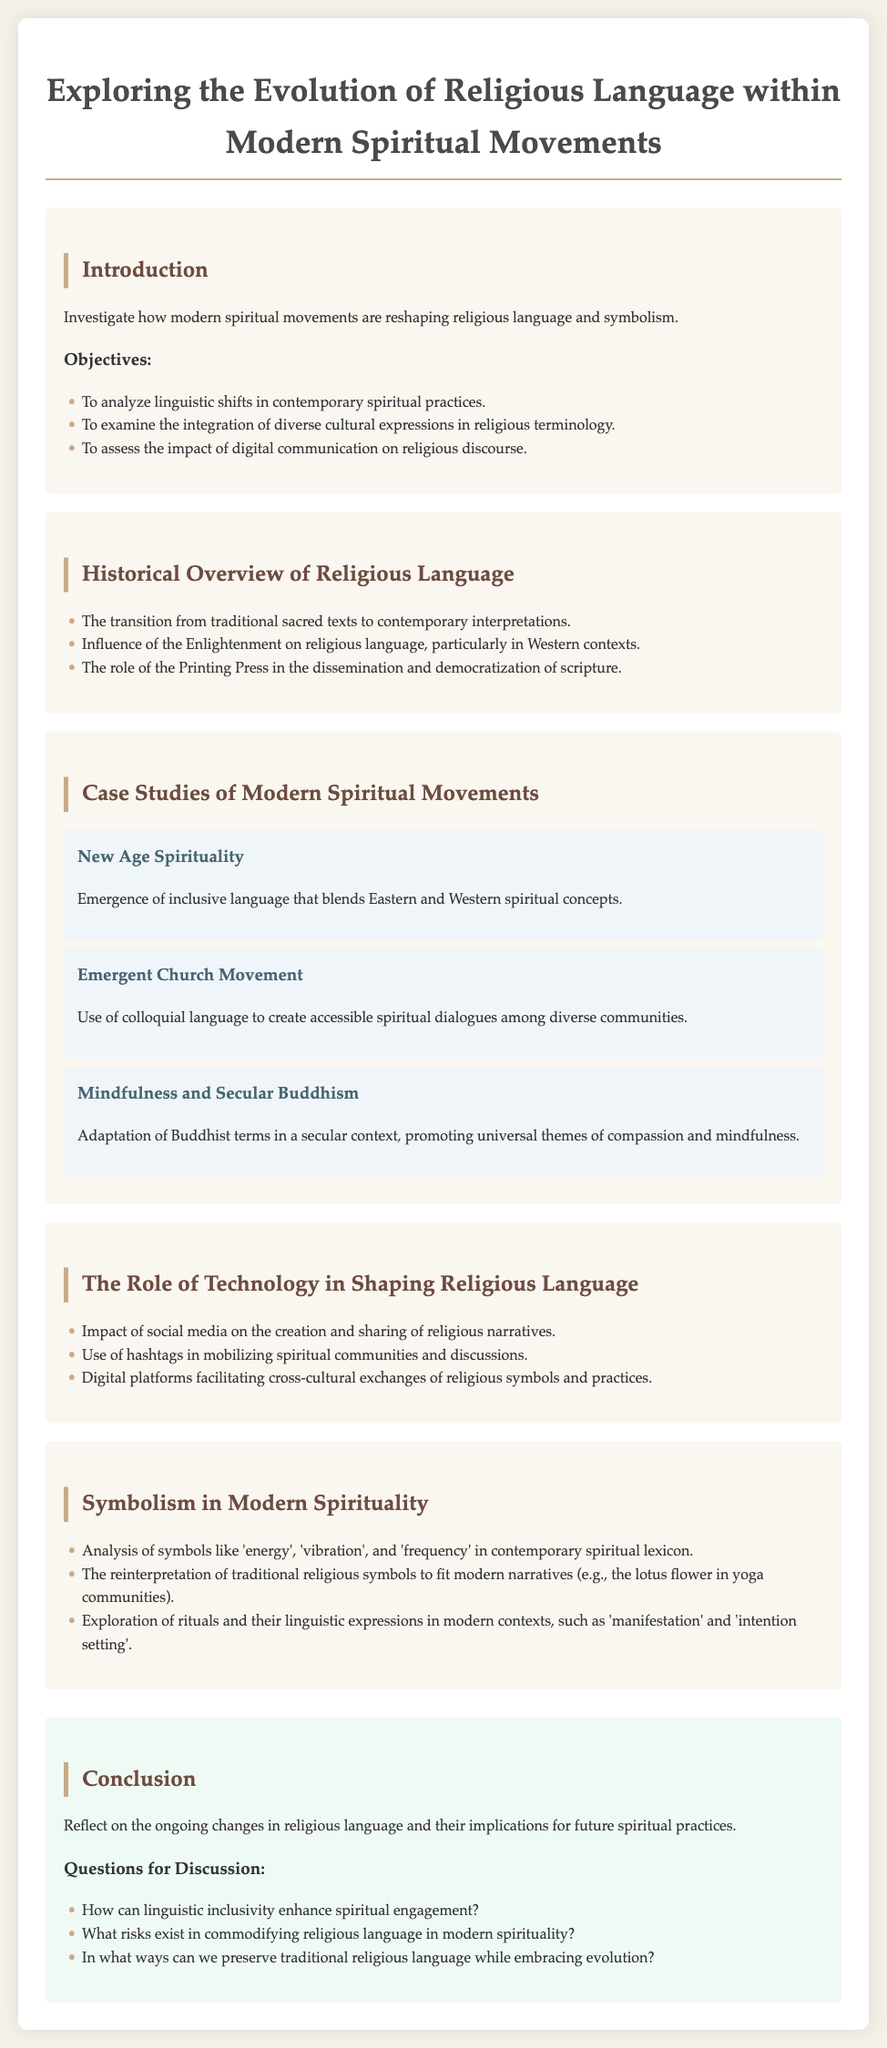What is the title of the document? The title is stated in the header of the document, which is "Exploring the Evolution of Religious Language within Modern Spiritual Movements."
Answer: Exploring the Evolution of Religious Language within Modern Spiritual Movements What are the three objectives mentioned in the Introduction? The objectives are listed under the "Objectives" heading and include analyzing linguistic shifts, examining integration of cultural expressions, and assessing impact of digital communication.
Answer: To analyze linguistic shifts in contemporary spiritual practices, To examine the integration of diverse cultural expressions in religious terminology, To assess the impact of digital communication on religious discourse Which case study discusses inclusive language? The case studies provide specific examples, and the one mentioning inclusive language is "New Age Spirituality."
Answer: New Age Spirituality What is the role of social media according to the document? The document outlines several impacts of social media, specifically its influence on narratives in the context of religion.
Answer: Impact of social media on the creation and sharing of religious narratives Which symbol is analyzed in the section on Symbolism in Modern Spirituality? The document lists several symbols discussed in this section; one of them is the 'lotus flower.'
Answer: 'lotus flower' How can linguistic inclusivity enhance spiritual engagement? This question is framed as a discussion prompt at the end of the document, encouraging continued exploration of the topic.
Answer: How can linguistic inclusivity enhance spiritual engagement? What is a risk mentioned in the conclusion regarding religious language? The document mentions that commodifying religious language poses certain risks in the modern spirituality context.
Answer: What risks exist in commodifying religious language in modern spirituality? What does the conclusion reflect on? The conclusion summarizes ongoing changes in religious language and their implications for future spiritual practices.
Answer: Ongoing changes in religious language and their implications for future spiritual practices 